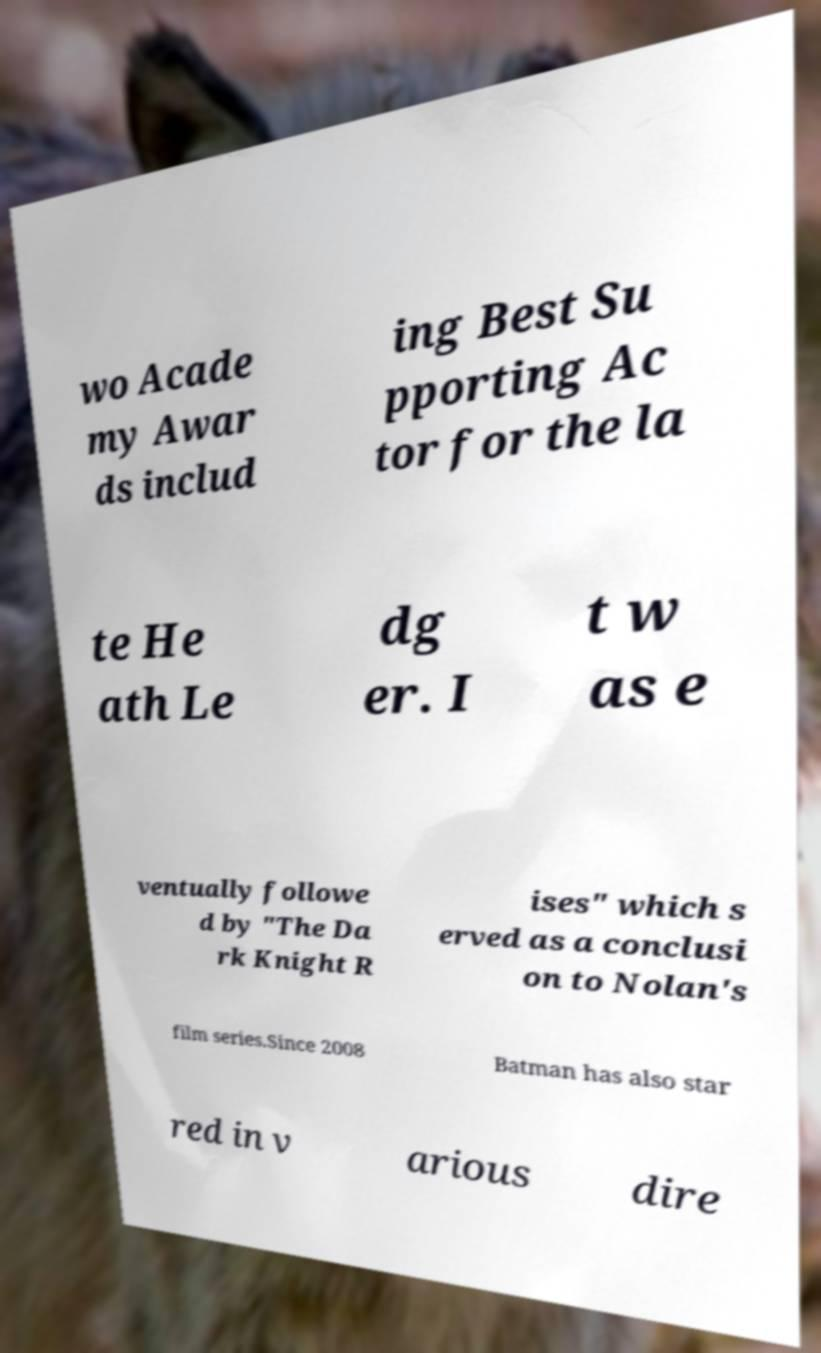Please read and relay the text visible in this image. What does it say? wo Acade my Awar ds includ ing Best Su pporting Ac tor for the la te He ath Le dg er. I t w as e ventually followe d by "The Da rk Knight R ises" which s erved as a conclusi on to Nolan's film series.Since 2008 Batman has also star red in v arious dire 